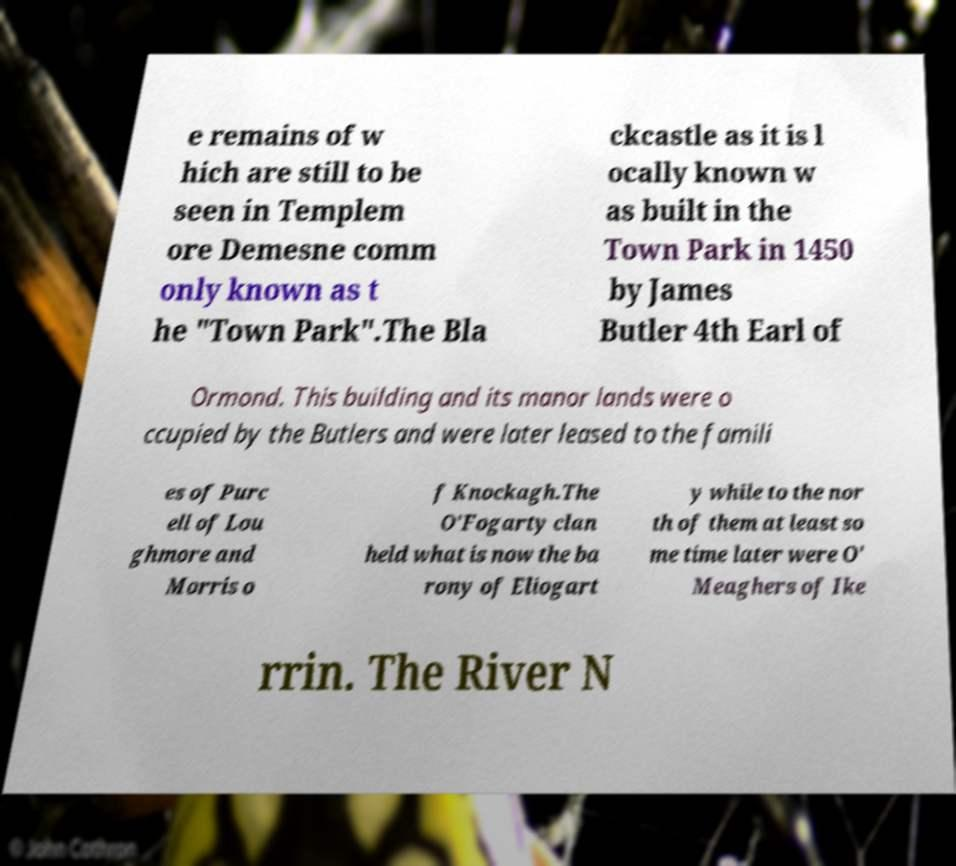For documentation purposes, I need the text within this image transcribed. Could you provide that? e remains of w hich are still to be seen in Templem ore Demesne comm only known as t he "Town Park".The Bla ckcastle as it is l ocally known w as built in the Town Park in 1450 by James Butler 4th Earl of Ormond. This building and its manor lands were o ccupied by the Butlers and were later leased to the famili es of Purc ell of Lou ghmore and Morris o f Knockagh.The O′Fogarty clan held what is now the ba rony of Eliogart y while to the nor th of them at least so me time later were O' Meaghers of Ike rrin. The River N 